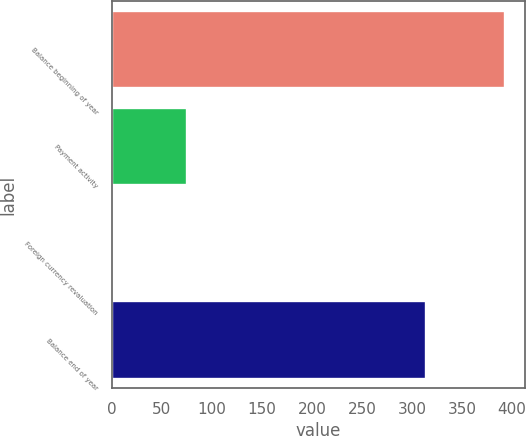<chart> <loc_0><loc_0><loc_500><loc_500><bar_chart><fcel>Balance beginning of year<fcel>Payment activity<fcel>Foreign currency revaluation<fcel>Balance end of year<nl><fcel>393<fcel>75<fcel>2<fcel>314<nl></chart> 